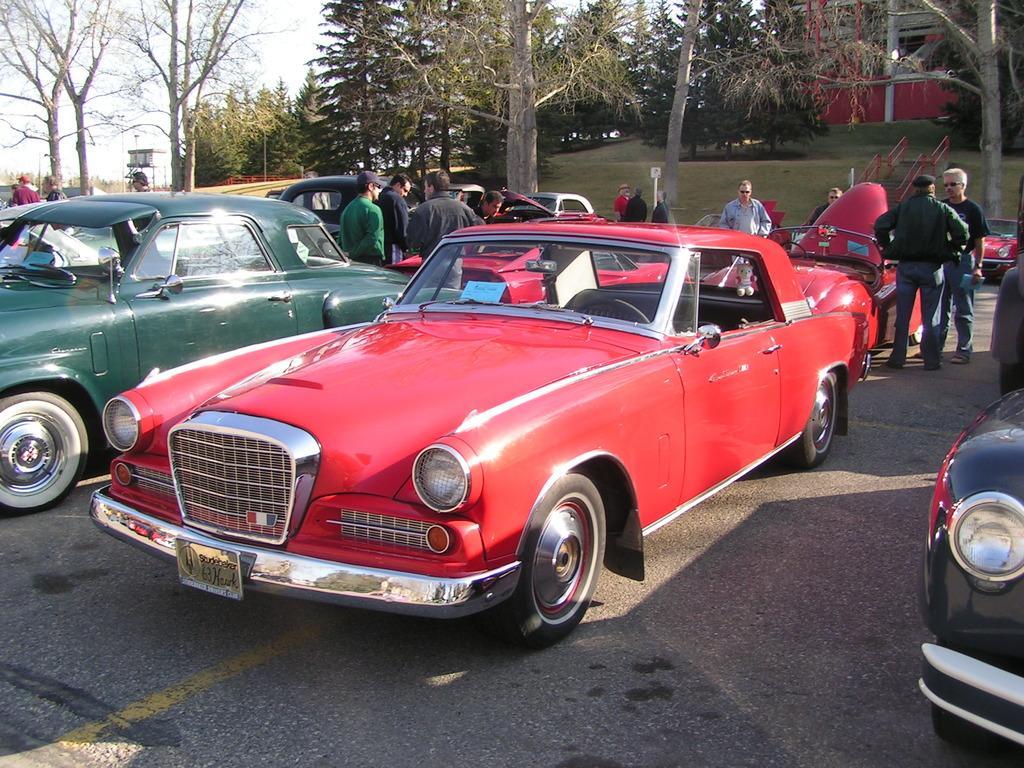How would you summarize this image in a sentence or two? In this picture we can see cars and a group of people standing on the road, trees, grass, steps, house and in the background we can see the sky. 